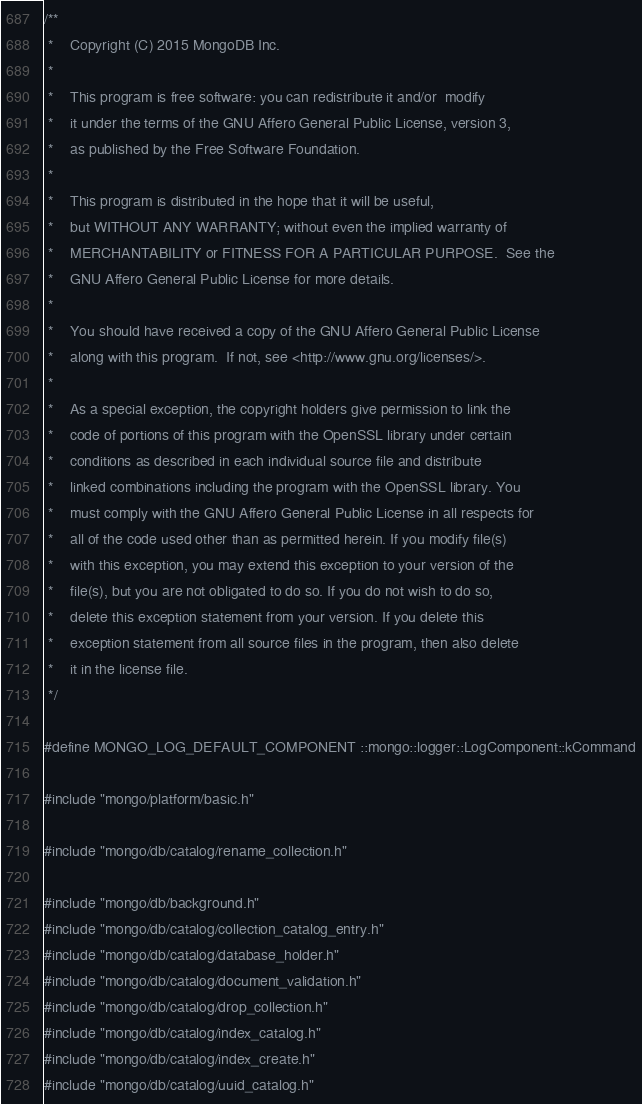<code> <loc_0><loc_0><loc_500><loc_500><_C++_>/**
 *    Copyright (C) 2015 MongoDB Inc.
 *
 *    This program is free software: you can redistribute it and/or  modify
 *    it under the terms of the GNU Affero General Public License, version 3,
 *    as published by the Free Software Foundation.
 *
 *    This program is distributed in the hope that it will be useful,
 *    but WITHOUT ANY WARRANTY; without even the implied warranty of
 *    MERCHANTABILITY or FITNESS FOR A PARTICULAR PURPOSE.  See the
 *    GNU Affero General Public License for more details.
 *
 *    You should have received a copy of the GNU Affero General Public License
 *    along with this program.  If not, see <http://www.gnu.org/licenses/>.
 *
 *    As a special exception, the copyright holders give permission to link the
 *    code of portions of this program with the OpenSSL library under certain
 *    conditions as described in each individual source file and distribute
 *    linked combinations including the program with the OpenSSL library. You
 *    must comply with the GNU Affero General Public License in all respects for
 *    all of the code used other than as permitted herein. If you modify file(s)
 *    with this exception, you may extend this exception to your version of the
 *    file(s), but you are not obligated to do so. If you do not wish to do so,
 *    delete this exception statement from your version. If you delete this
 *    exception statement from all source files in the program, then also delete
 *    it in the license file.
 */

#define MONGO_LOG_DEFAULT_COMPONENT ::mongo::logger::LogComponent::kCommand

#include "mongo/platform/basic.h"

#include "mongo/db/catalog/rename_collection.h"

#include "mongo/db/background.h"
#include "mongo/db/catalog/collection_catalog_entry.h"
#include "mongo/db/catalog/database_holder.h"
#include "mongo/db/catalog/document_validation.h"
#include "mongo/db/catalog/drop_collection.h"
#include "mongo/db/catalog/index_catalog.h"
#include "mongo/db/catalog/index_create.h"
#include "mongo/db/catalog/uuid_catalog.h"</code> 